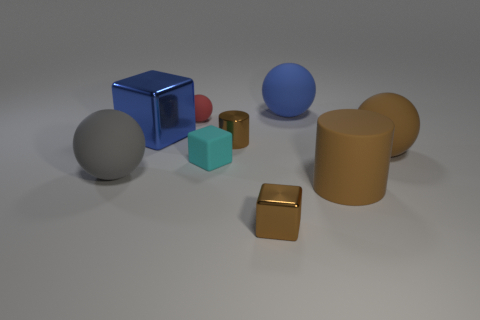What materials do the objects in the image appear to be made of? The objects in the image seem to display characteristics of various materials. The blue cuboid has a matte surface, suggesting it could be made of painted metal or plastic. The small cyan cube appears to have a slightly reflective surface hinting at a plastic or polished stone material. The grey sphere might be metallic due to its sheen, while the gold cuboid seems to resemble brushed metal, and the brownish cylinders look to have a matte clay-like texture. 